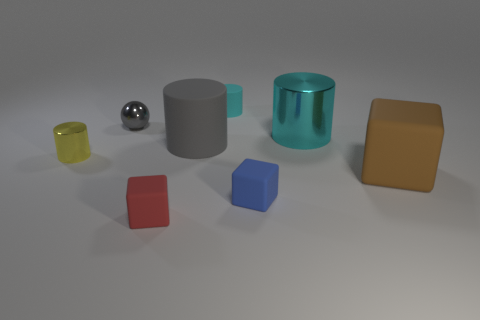Can you describe the lighting in the scene and how it affects the appearance of the objects? The lighting in the image appears to be soft and diffused, coming from above as suggested by the shadow pattern beneath the objects. This lighting condition enhances the visibility of the objects' colors and textures while minimizing harsh shadows. It contributes to the clarity of the materials' surfaces, such as the matte finish of some objects and the reflective quality of others. 